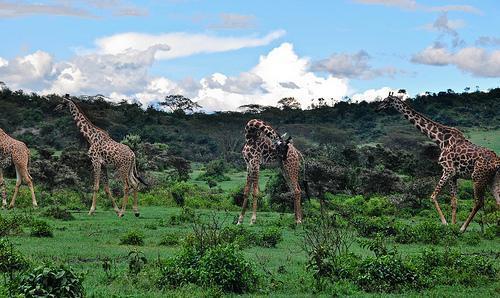How many giraffes are there?
Give a very brief answer. 4. 